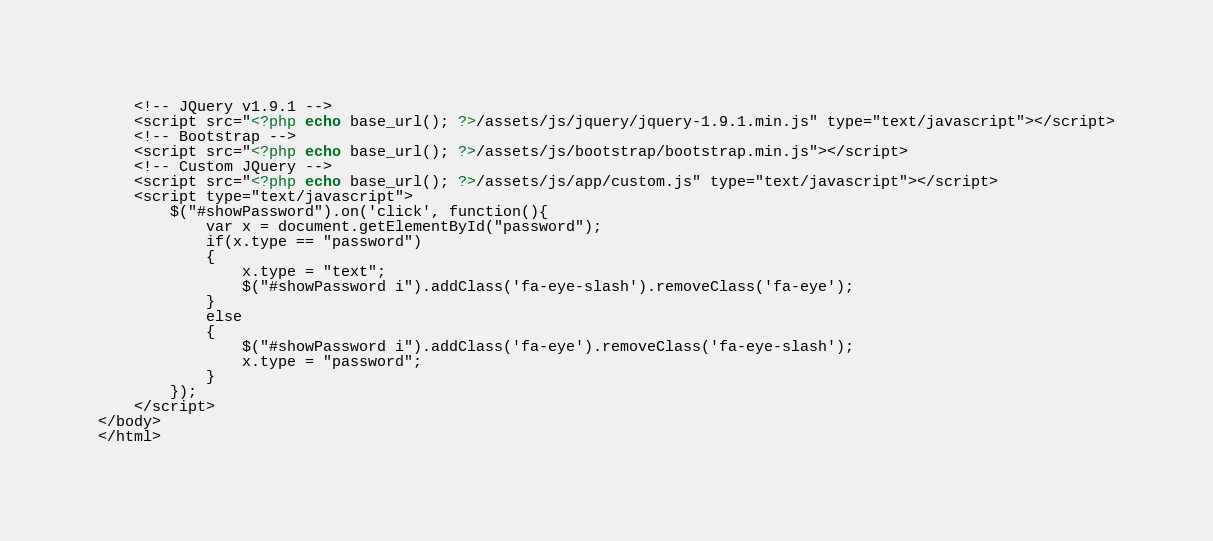Convert code to text. <code><loc_0><loc_0><loc_500><loc_500><_PHP_>    <!-- JQuery v1.9.1 -->
	<script src="<?php echo base_url(); ?>/assets/js/jquery/jquery-1.9.1.min.js" type="text/javascript"></script>
    <!-- Bootstrap -->
    <script src="<?php echo base_url(); ?>/assets/js/bootstrap/bootstrap.min.js"></script>
    <!-- Custom JQuery -->
	<script src="<?php echo base_url(); ?>/assets/js/app/custom.js" type="text/javascript"></script>
	<script type="text/javascript">
		$("#showPassword").on('click', function(){
			var x = document.getElementById("password");
			if(x.type == "password")
			{
				x.type = "text";
				$("#showPassword i").addClass('fa-eye-slash').removeClass('fa-eye');
			}
			else 
			{
				$("#showPassword i").addClass('fa-eye').removeClass('fa-eye-slash');
				x.type = "password";	
			}
		});
	</script>
</body>
</html>
</code> 